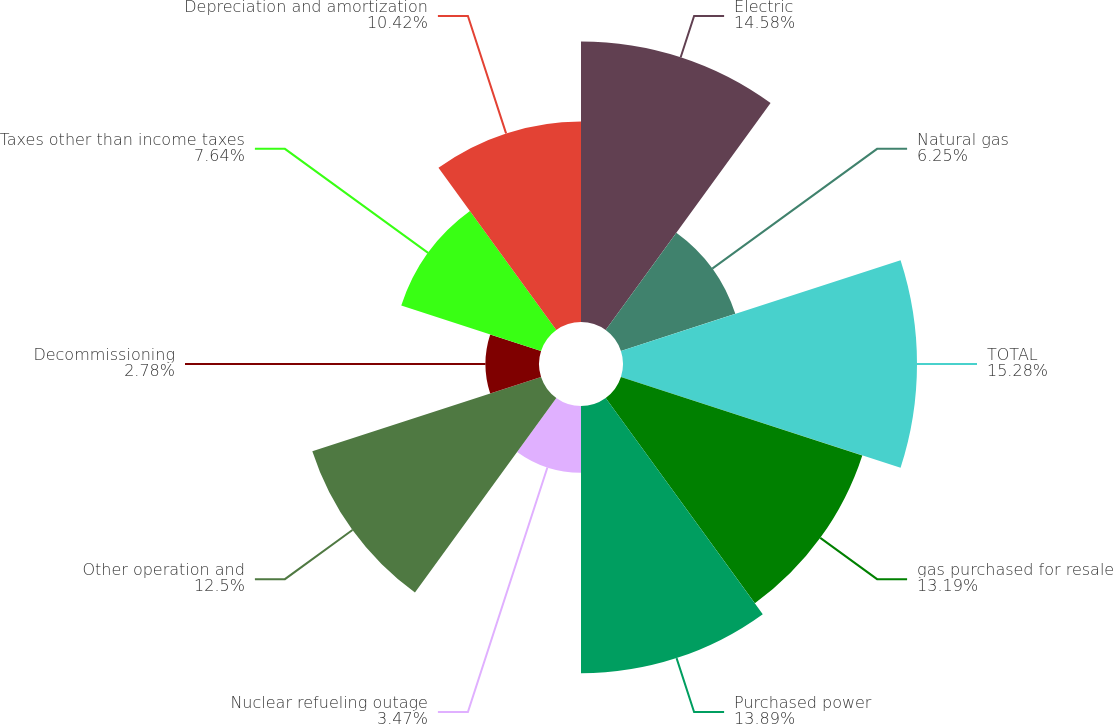Convert chart. <chart><loc_0><loc_0><loc_500><loc_500><pie_chart><fcel>Electric<fcel>Natural gas<fcel>TOTAL<fcel>gas purchased for resale<fcel>Purchased power<fcel>Nuclear refueling outage<fcel>Other operation and<fcel>Decommissioning<fcel>Taxes other than income taxes<fcel>Depreciation and amortization<nl><fcel>14.58%<fcel>6.25%<fcel>15.28%<fcel>13.19%<fcel>13.89%<fcel>3.47%<fcel>12.5%<fcel>2.78%<fcel>7.64%<fcel>10.42%<nl></chart> 